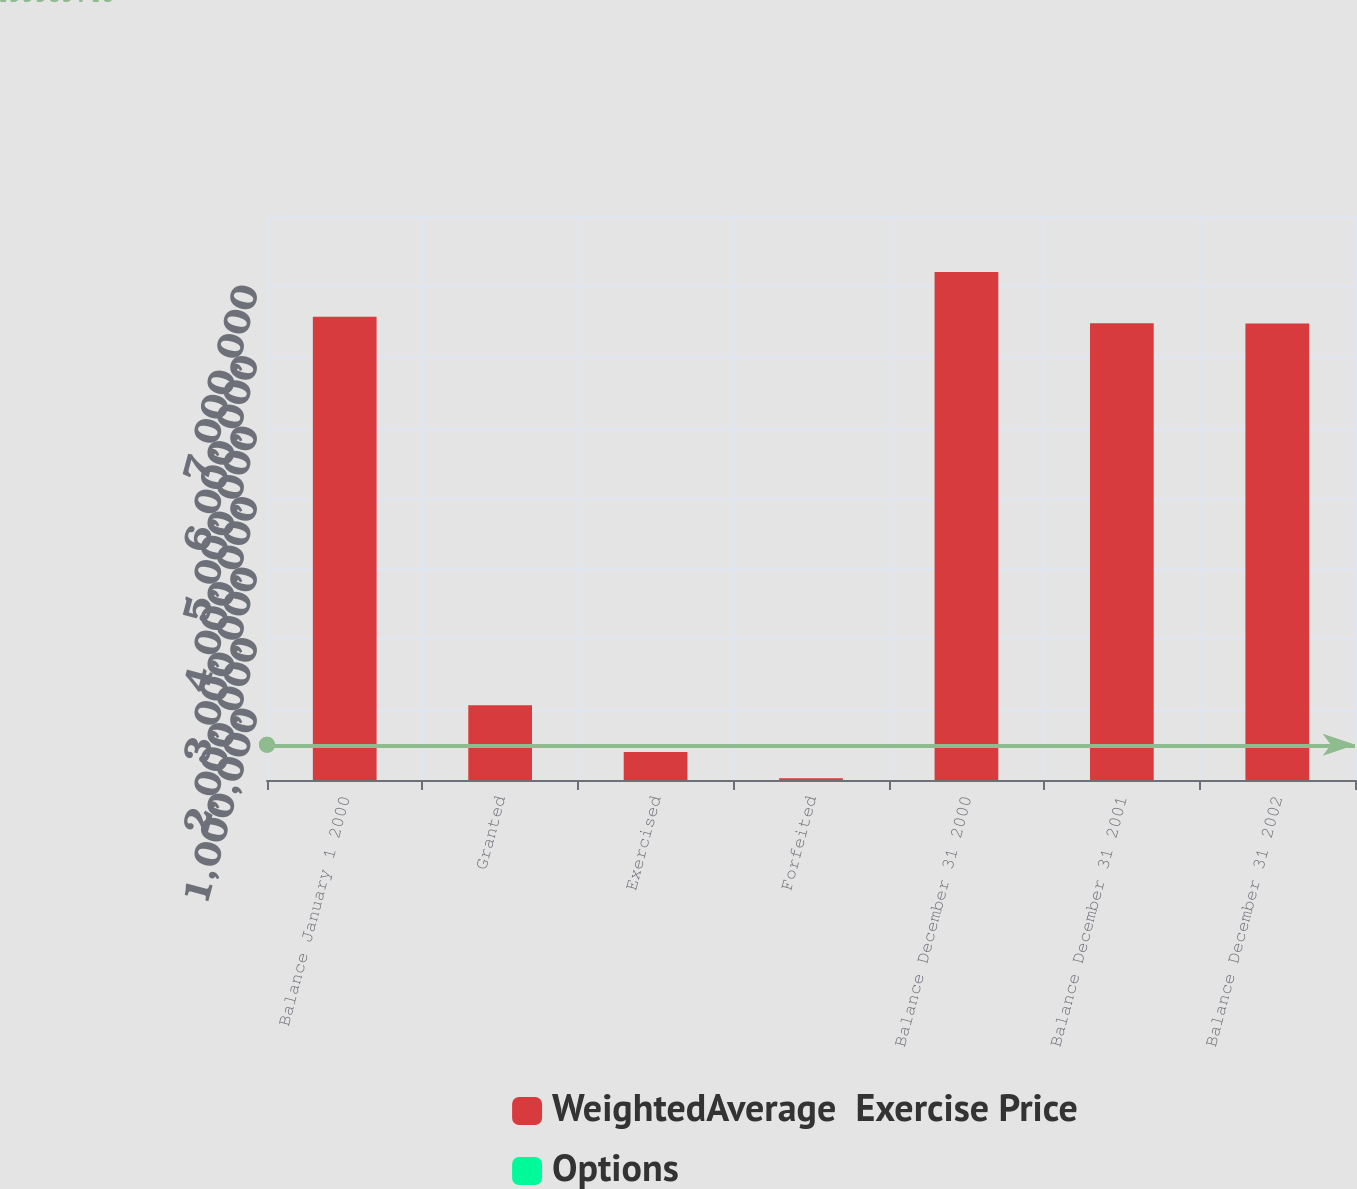Convert chart. <chart><loc_0><loc_0><loc_500><loc_500><stacked_bar_chart><ecel><fcel>Balance January 1 2000<fcel>Granted<fcel>Exercised<fcel>Forfeited<fcel>Balance December 31 2000<fcel>Balance December 31 2001<fcel>Balance December 31 2002<nl><fcel>WeightedAverage  Exercise Price<fcel>6.5692e+06<fcel>1.0597e+06<fcel>398138<fcel>26560<fcel>7.2042e+06<fcel>6.47844e+06<fcel>6.4741e+06<nl><fcel>Options<fcel>4.55<fcel>11.92<fcel>4.55<fcel>6.88<fcel>5.62<fcel>7.31<fcel>9.1<nl></chart> 